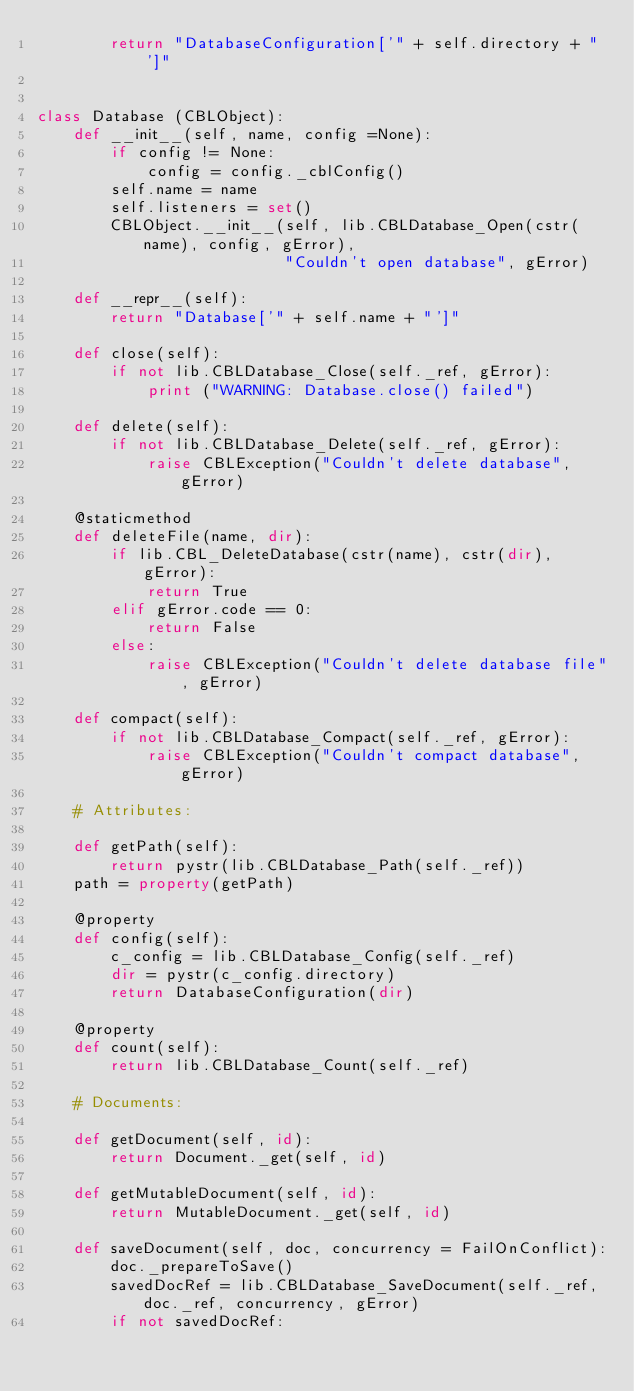<code> <loc_0><loc_0><loc_500><loc_500><_Python_>        return "DatabaseConfiguration['" + self.directory + "']"


class Database (CBLObject):
    def __init__(self, name, config =None):
        if config != None:
            config = config._cblConfig()
        self.name = name
        self.listeners = set()
        CBLObject.__init__(self, lib.CBLDatabase_Open(cstr(name), config, gError),
                           "Couldn't open database", gError)

    def __repr__(self):
        return "Database['" + self.name + "']"

    def close(self):
        if not lib.CBLDatabase_Close(self._ref, gError):
            print ("WARNING: Database.close() failed")

    def delete(self):
        if not lib.CBLDatabase_Delete(self._ref, gError):
            raise CBLException("Couldn't delete database", gError)

    @staticmethod
    def deleteFile(name, dir):
        if lib.CBL_DeleteDatabase(cstr(name), cstr(dir), gError):
            return True
        elif gError.code == 0:
            return False
        else:
            raise CBLException("Couldn't delete database file", gError)

    def compact(self):
        if not lib.CBLDatabase_Compact(self._ref, gError):
            raise CBLException("Couldn't compact database", gError)

    # Attributes:

    def getPath(self):
        return pystr(lib.CBLDatabase_Path(self._ref))
    path = property(getPath)

    @property
    def config(self):
        c_config = lib.CBLDatabase_Config(self._ref)
        dir = pystr(c_config.directory)
        return DatabaseConfiguration(dir)

    @property
    def count(self):
        return lib.CBLDatabase_Count(self._ref)

    # Documents:

    def getDocument(self, id):
        return Document._get(self, id)

    def getMutableDocument(self, id):
        return MutableDocument._get(self, id)

    def saveDocument(self, doc, concurrency = FailOnConflict):
        doc._prepareToSave()
        savedDocRef = lib.CBLDatabase_SaveDocument(self._ref, doc._ref, concurrency, gError)
        if not savedDocRef:</code> 